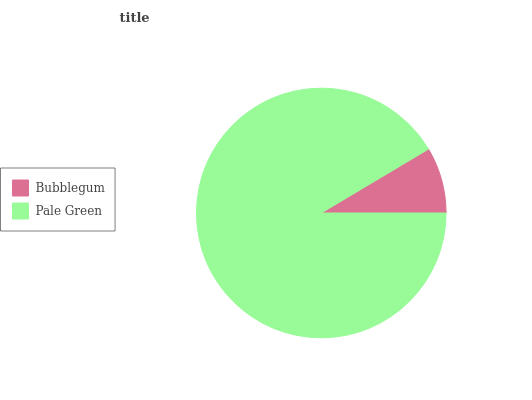Is Bubblegum the minimum?
Answer yes or no. Yes. Is Pale Green the maximum?
Answer yes or no. Yes. Is Pale Green the minimum?
Answer yes or no. No. Is Pale Green greater than Bubblegum?
Answer yes or no. Yes. Is Bubblegum less than Pale Green?
Answer yes or no. Yes. Is Bubblegum greater than Pale Green?
Answer yes or no. No. Is Pale Green less than Bubblegum?
Answer yes or no. No. Is Pale Green the high median?
Answer yes or no. Yes. Is Bubblegum the low median?
Answer yes or no. Yes. Is Bubblegum the high median?
Answer yes or no. No. Is Pale Green the low median?
Answer yes or no. No. 